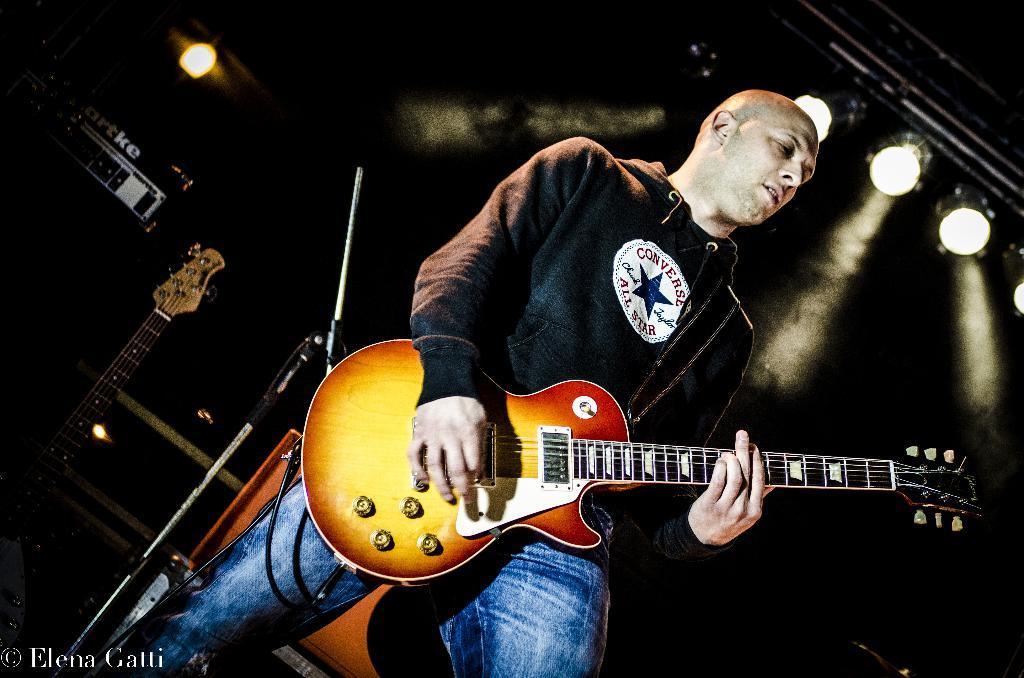Describe this image in one or two sentences. In this picture we can see a man standing and playing guitar with his hands and in the background we can see a mic stand, guitar, lights. 